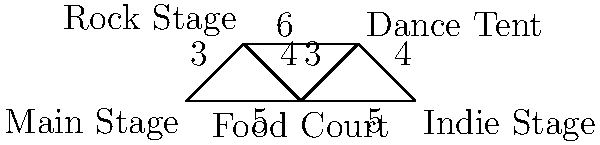At Rock Zottegem, you want to go from the Main Stage to the Indie Stage. Given the festival map graph above, where each edge represents a path between locations and the numbers indicate the walking time in minutes, what is the shortest time (in minutes) it would take to reach the Indie Stage from the Main Stage? To find the shortest path from the Main Stage to the Indie Stage, we need to consider all possible routes and their total times:

1. Main Stage → Rock Stage → Food Court → Dance Tent → Indie Stage
   Time: 3 + 4 + 3 + 4 = 14 minutes

2. Main Stage → Food Court → Dance Tent → Indie Stage
   Time: 5 + 3 + 4 = 12 minutes

3. Main Stage → Food Court → Indie Stage
   Time: 5 + 5 = 10 minutes

The shortest path is the third option, taking 10 minutes.
Answer: 10 minutes 